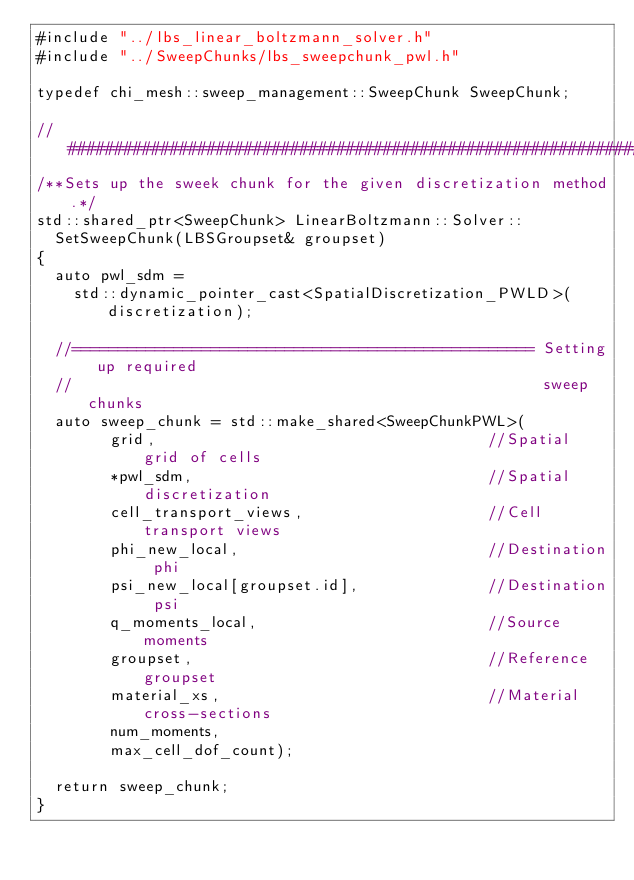<code> <loc_0><loc_0><loc_500><loc_500><_C++_>#include "../lbs_linear_boltzmann_solver.h"
#include "../SweepChunks/lbs_sweepchunk_pwl.h"

typedef chi_mesh::sweep_management::SweepChunk SweepChunk;

//###################################################################
/**Sets up the sweek chunk for the given discretization method.*/
std::shared_ptr<SweepChunk> LinearBoltzmann::Solver::
  SetSweepChunk(LBSGroupset& groupset)
{
  auto pwl_sdm =
    std::dynamic_pointer_cast<SpatialDiscretization_PWLD>(discretization);

  //================================================== Setting up required
  //                                                   sweep chunks
  auto sweep_chunk = std::make_shared<SweepChunkPWL>(
        grid,                                    //Spatial grid of cells
        *pwl_sdm,                                //Spatial discretization
        cell_transport_views,                    //Cell transport views
        phi_new_local,                           //Destination phi
        psi_new_local[groupset.id],              //Destination psi
        q_moments_local,                         //Source moments
        groupset,                                //Reference groupset
        material_xs,                             //Material cross-sections
        num_moments,
        max_cell_dof_count);

  return sweep_chunk;
}
</code> 